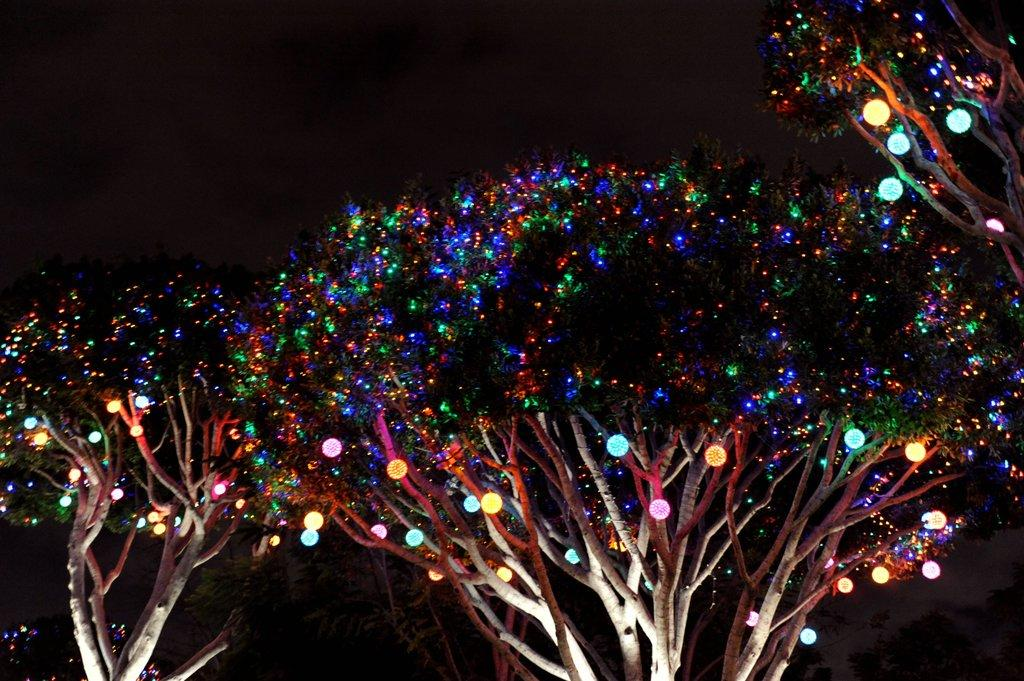What type of vegetation is visible in the image? There are trees in the image. Do the trees have any special features? Yes, the trees have decorative lights. What is the color of the background in the image? The background of the image is dark. How many feathers can be seen on the chicken in the image? There is no chicken present in the image. What type of acoustics can be heard coming from the trees in the image? There is no sound or acoustics mentioned or visible in the image. 